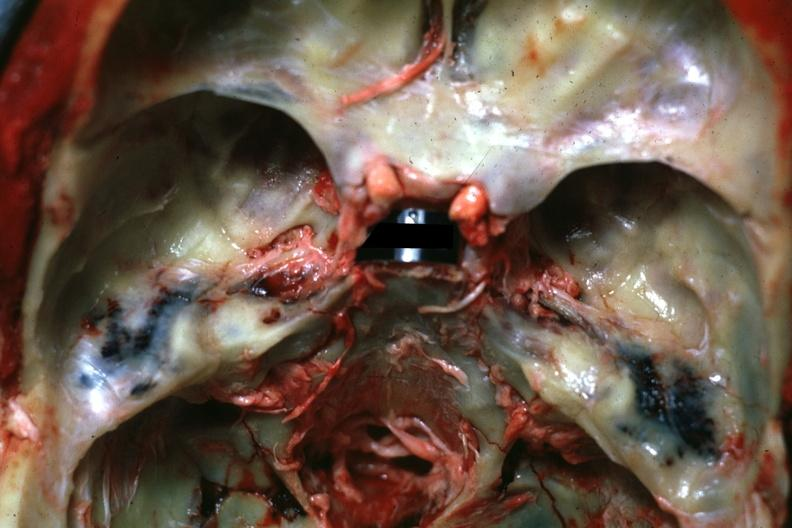does amyloidosis show view of middle ear areas with obvious hemorrhage in under-lying tissue?
Answer the question using a single word or phrase. No 